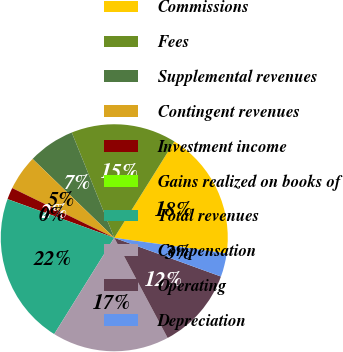Convert chart to OTSL. <chart><loc_0><loc_0><loc_500><loc_500><pie_chart><fcel>Commissions<fcel>Fees<fcel>Supplemental revenues<fcel>Contingent revenues<fcel>Investment income<fcel>Gains realized on books of<fcel>Total revenues<fcel>Compensation<fcel>Operating<fcel>Depreciation<nl><fcel>18.32%<fcel>14.99%<fcel>6.67%<fcel>5.01%<fcel>1.68%<fcel>0.01%<fcel>21.65%<fcel>16.66%<fcel>11.66%<fcel>3.34%<nl></chart> 